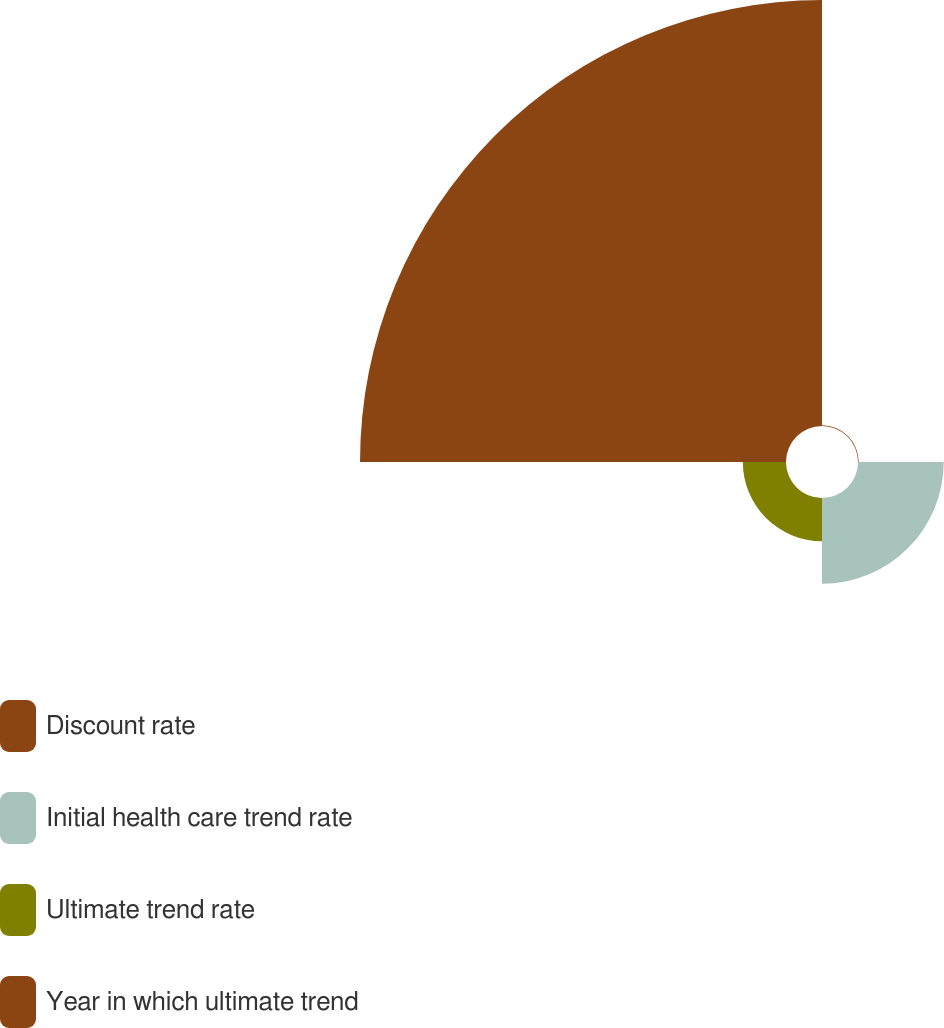Convert chart. <chart><loc_0><loc_0><loc_500><loc_500><pie_chart><fcel>Discount rate<fcel>Initial health care trend rate<fcel>Ultimate trend rate<fcel>Year in which ultimate trend<nl><fcel>0.12%<fcel>15.43%<fcel>7.77%<fcel>76.68%<nl></chart> 